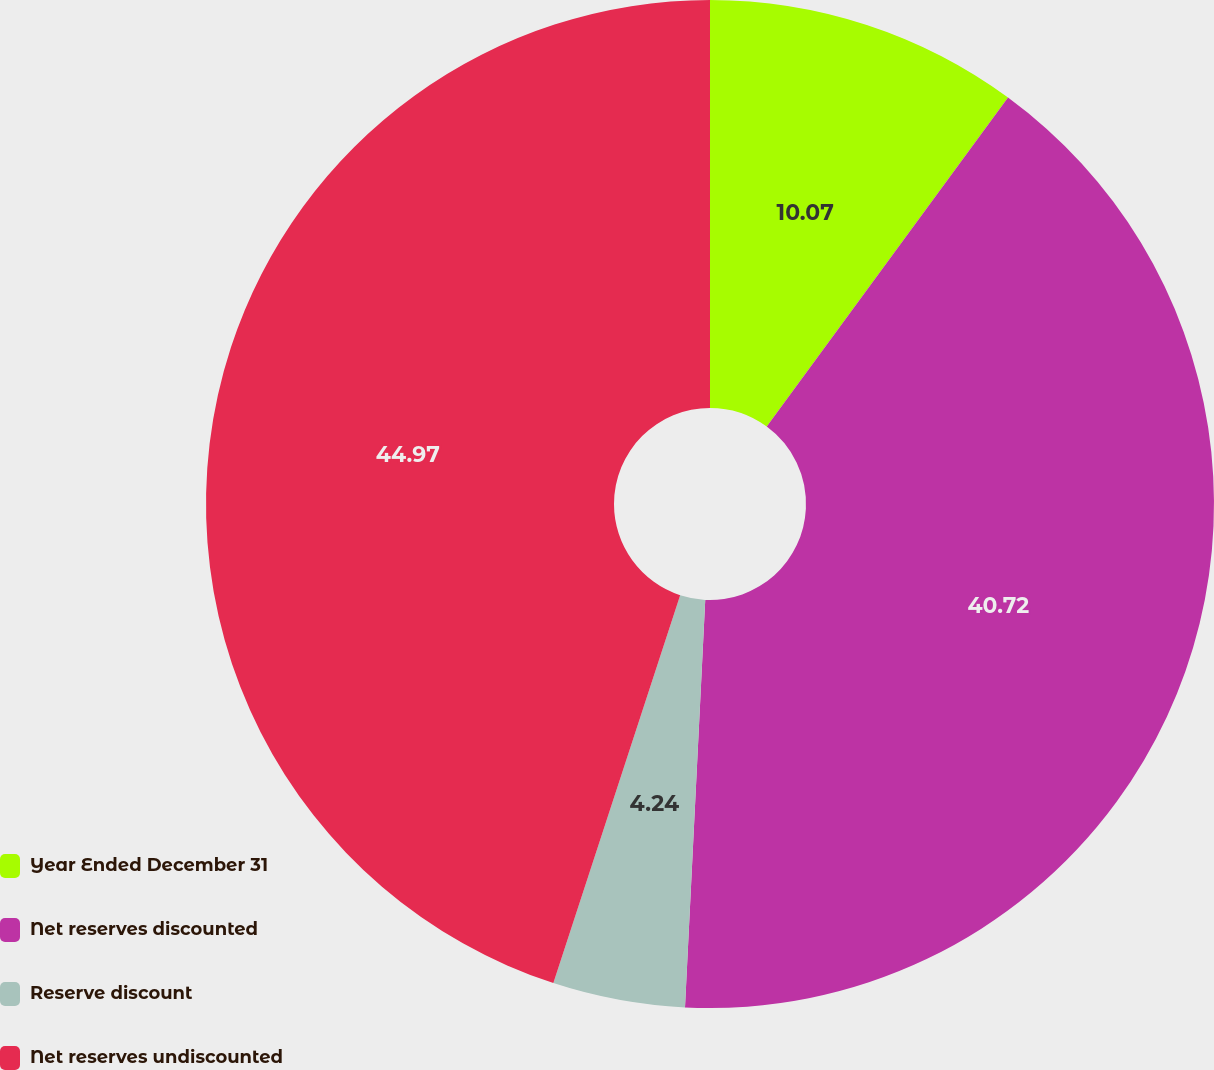Convert chart to OTSL. <chart><loc_0><loc_0><loc_500><loc_500><pie_chart><fcel>Year Ended December 31<fcel>Net reserves discounted<fcel>Reserve discount<fcel>Net reserves undiscounted<nl><fcel>10.07%<fcel>40.72%<fcel>4.24%<fcel>44.97%<nl></chart> 